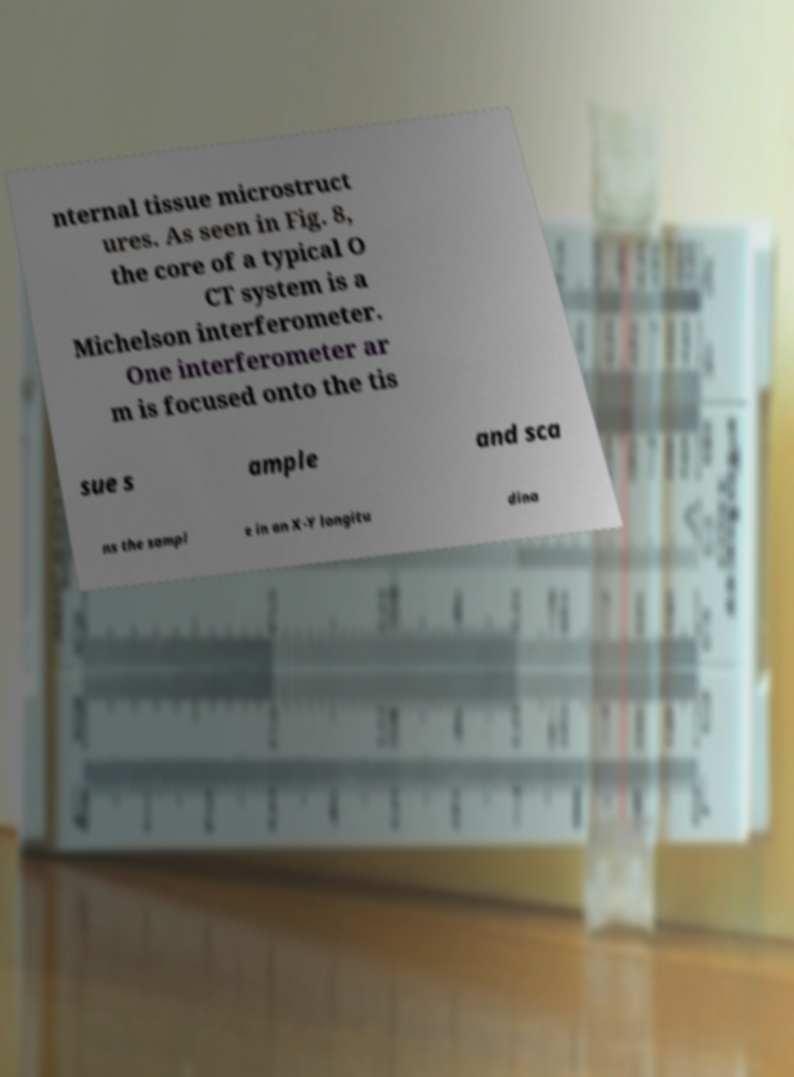Can you accurately transcribe the text from the provided image for me? nternal tissue microstruct ures. As seen in Fig. 8, the core of a typical O CT system is a Michelson interferometer. One interferometer ar m is focused onto the tis sue s ample and sca ns the sampl e in an X-Y longitu dina 